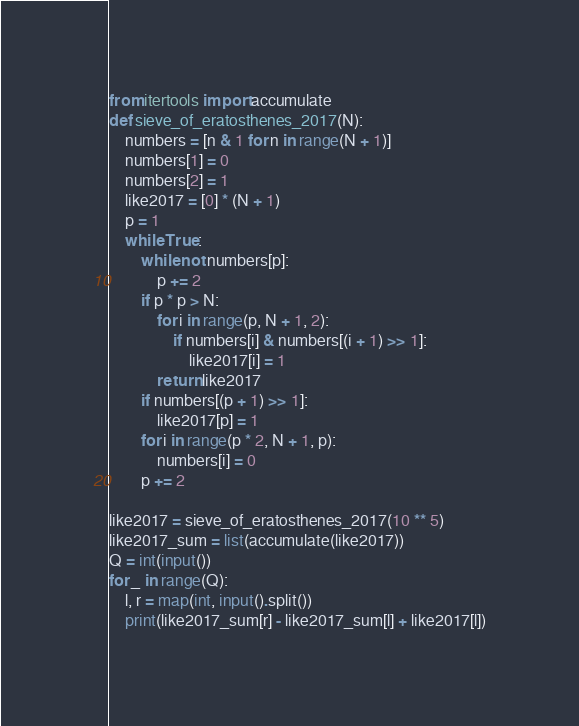<code> <loc_0><loc_0><loc_500><loc_500><_Python_>from itertools import accumulate
def sieve_of_eratosthenes_2017(N):
    numbers = [n & 1 for n in range(N + 1)]
    numbers[1] = 0
    numbers[2] = 1
    like2017 = [0] * (N + 1)
    p = 1
    while True:
        while not numbers[p]:
            p += 2
        if p * p > N:
            for i in range(p, N + 1, 2):
                if numbers[i] & numbers[(i + 1) >> 1]:
                    like2017[i] = 1
            return like2017
        if numbers[(p + 1) >> 1]:
            like2017[p] = 1
        for i in range(p * 2, N + 1, p):
            numbers[i] = 0
        p += 2

like2017 = sieve_of_eratosthenes_2017(10 ** 5)
like2017_sum = list(accumulate(like2017))
Q = int(input())
for _ in range(Q):
    l, r = map(int, input().split())
    print(like2017_sum[r] - like2017_sum[l] + like2017[l])</code> 